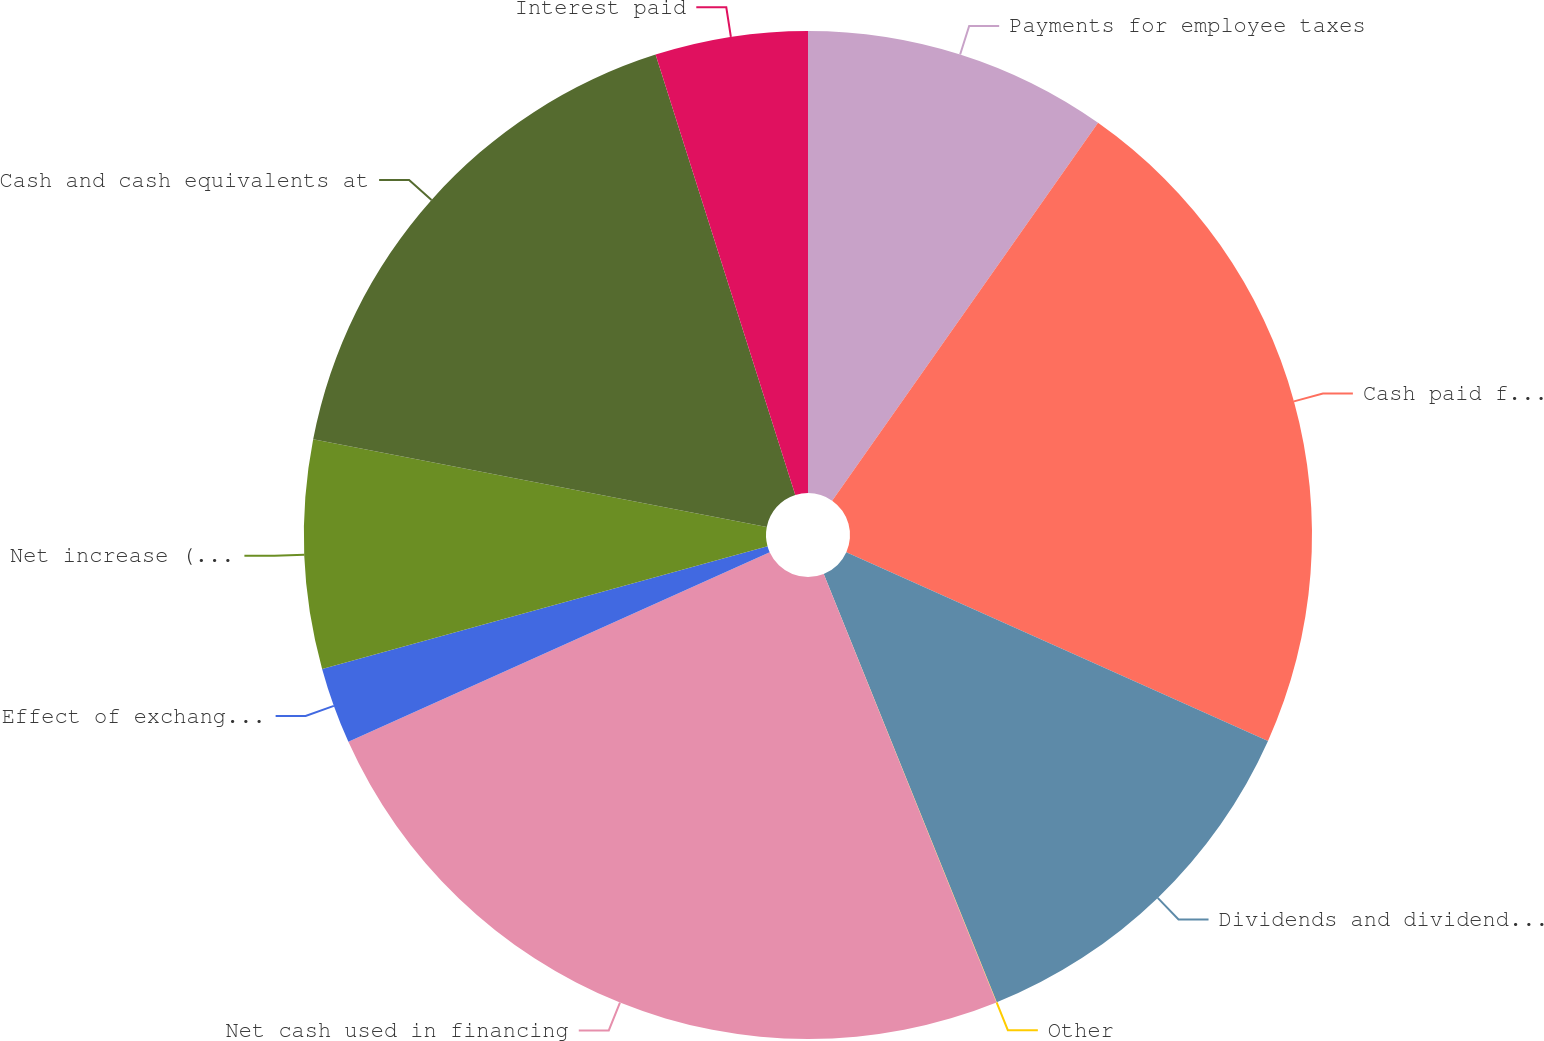Convert chart to OTSL. <chart><loc_0><loc_0><loc_500><loc_500><pie_chart><fcel>Payments for employee taxes<fcel>Cash paid for purchases of<fcel>Dividends and dividend rights<fcel>Other<fcel>Net cash used in financing<fcel>Effect of exchange rates on<fcel>Net increase (decrease) in<fcel>Cash and cash equivalents at<fcel>Interest paid<nl><fcel>9.76%<fcel>21.94%<fcel>12.19%<fcel>0.01%<fcel>24.37%<fcel>2.45%<fcel>7.32%<fcel>17.07%<fcel>4.89%<nl></chart> 